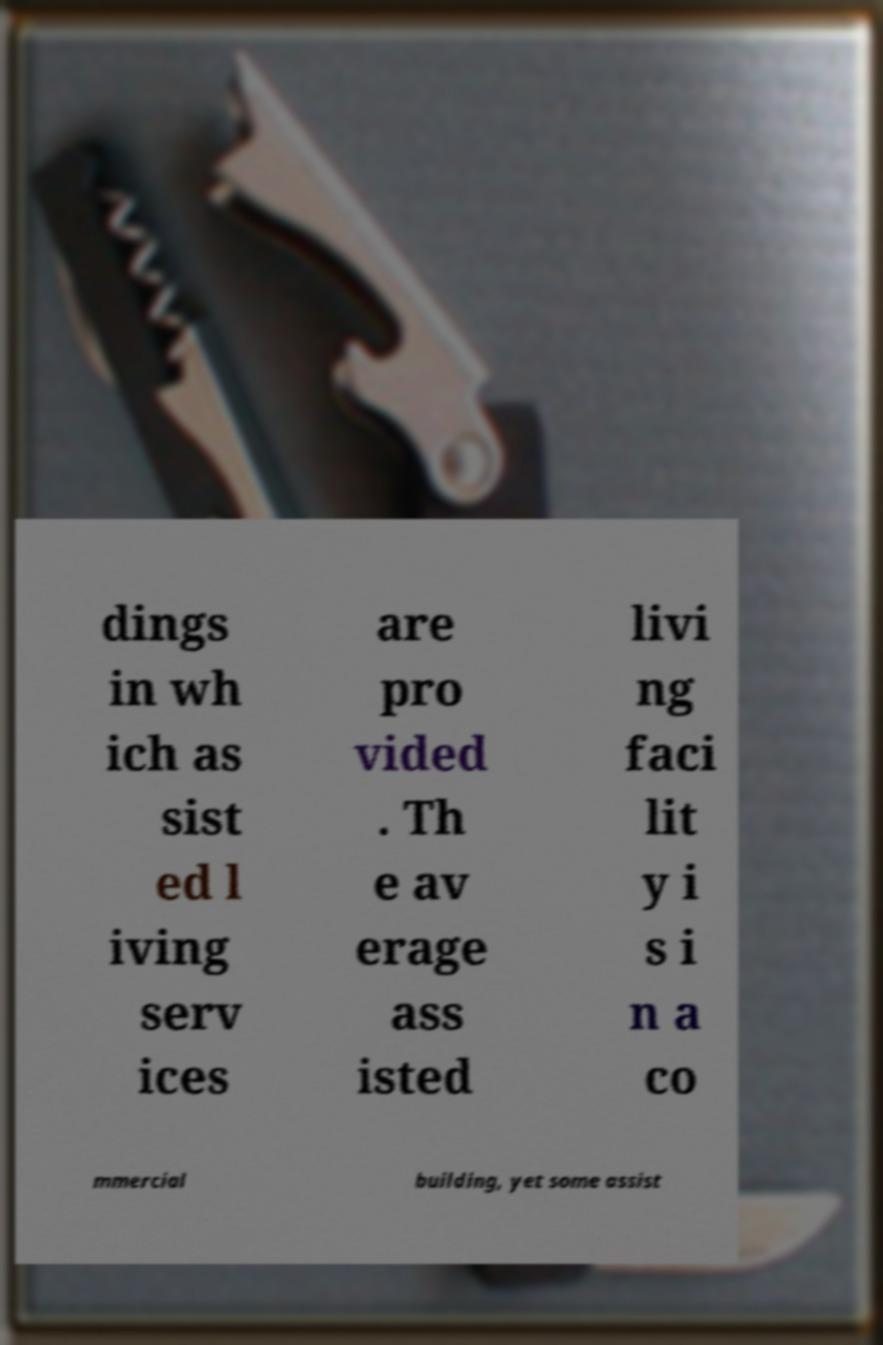For documentation purposes, I need the text within this image transcribed. Could you provide that? dings in wh ich as sist ed l iving serv ices are pro vided . Th e av erage ass isted livi ng faci lit y i s i n a co mmercial building, yet some assist 